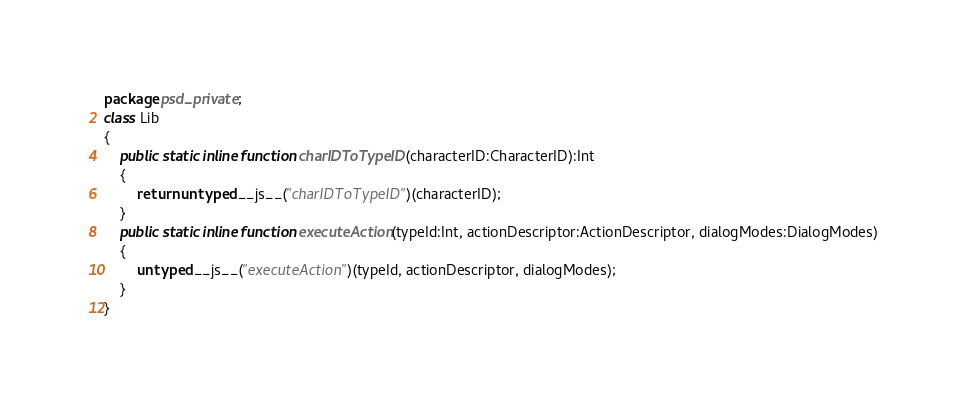Convert code to text. <code><loc_0><loc_0><loc_500><loc_500><_Haxe_>package psd_private;
class Lib
{
	public static inline function charIDToTypeID(characterID:CharacterID):Int
	{
		return untyped __js__("charIDToTypeID")(characterID);
	}
	public static inline function executeAction(typeId:Int, actionDescriptor:ActionDescriptor, dialogModes:DialogModes)
	{
		untyped __js__("executeAction")(typeId, actionDescriptor, dialogModes);
	}
}
</code> 